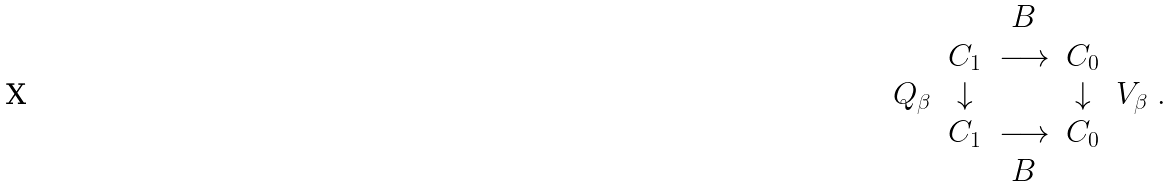<formula> <loc_0><loc_0><loc_500><loc_500>\begin{array} { c c c c c } & & B & & \\ & C _ { 1 } & \longrightarrow & C _ { 0 } & \\ Q _ { \beta } & \downarrow & & \downarrow & V _ { \beta } \\ & C _ { 1 } & \longrightarrow & C _ { 0 } & \\ & & B & & \end{array} .</formula> 